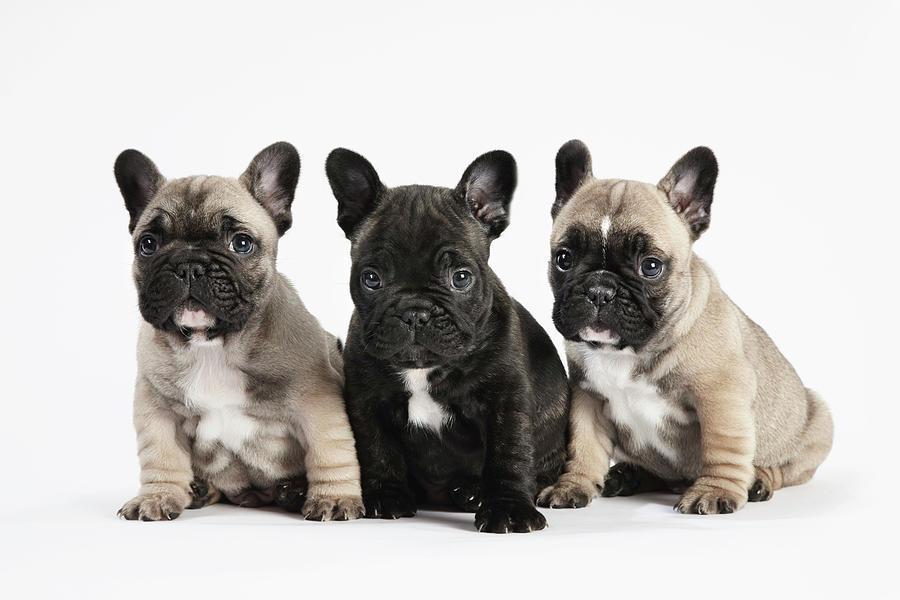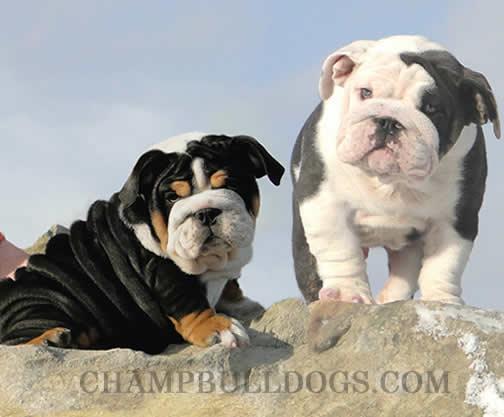The first image is the image on the left, the second image is the image on the right. Given the left and right images, does the statement "The right image contains exactly three dogs." hold true? Answer yes or no. No. The first image is the image on the left, the second image is the image on the right. Examine the images to the left and right. Is the description "There are no more than five puppies in the pair of images." accurate? Answer yes or no. Yes. 